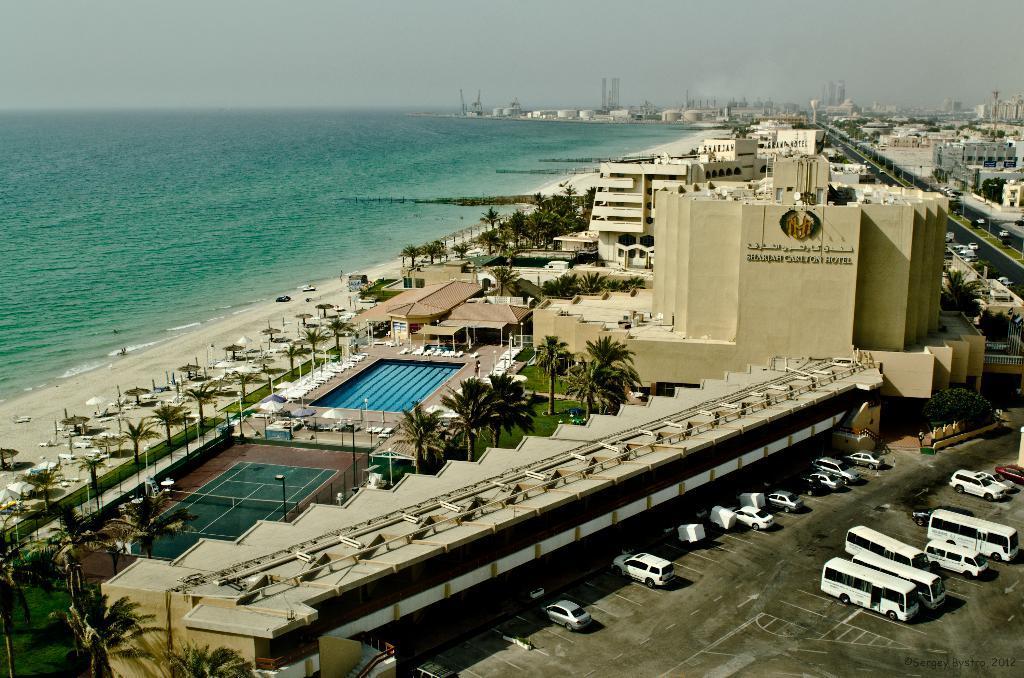In one or two sentences, can you explain what this image depicts? In this image I can see few vehicles parking, at back I can see few buildings in cream and white color, trees in green color and food ball court, swimming pool. At back I can see water in green color and sky is in gray color. 